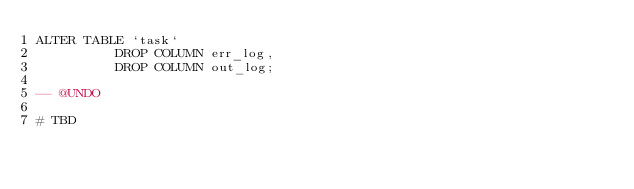<code> <loc_0><loc_0><loc_500><loc_500><_SQL_>ALTER TABLE `task`
          DROP COLUMN err_log,
          DROP COLUMN out_log;

-- @UNDO

# TBD</code> 